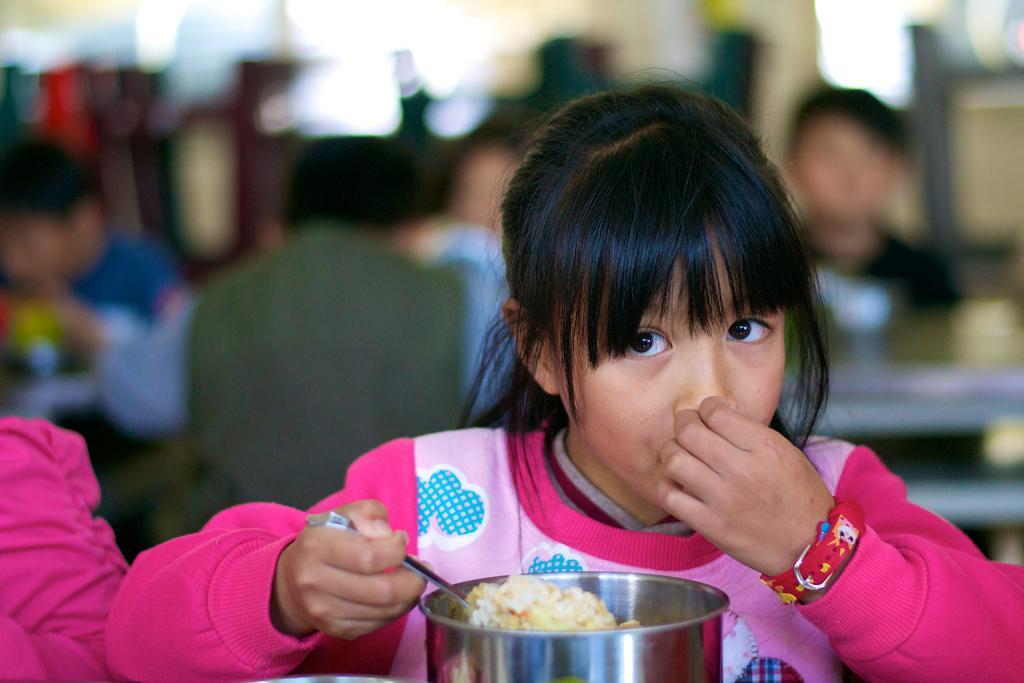Can you describe this image briefly? In this picture there is a small girl wearing a pink color top, sitting and eating the food from the silver box. Behind there is a blur background. 